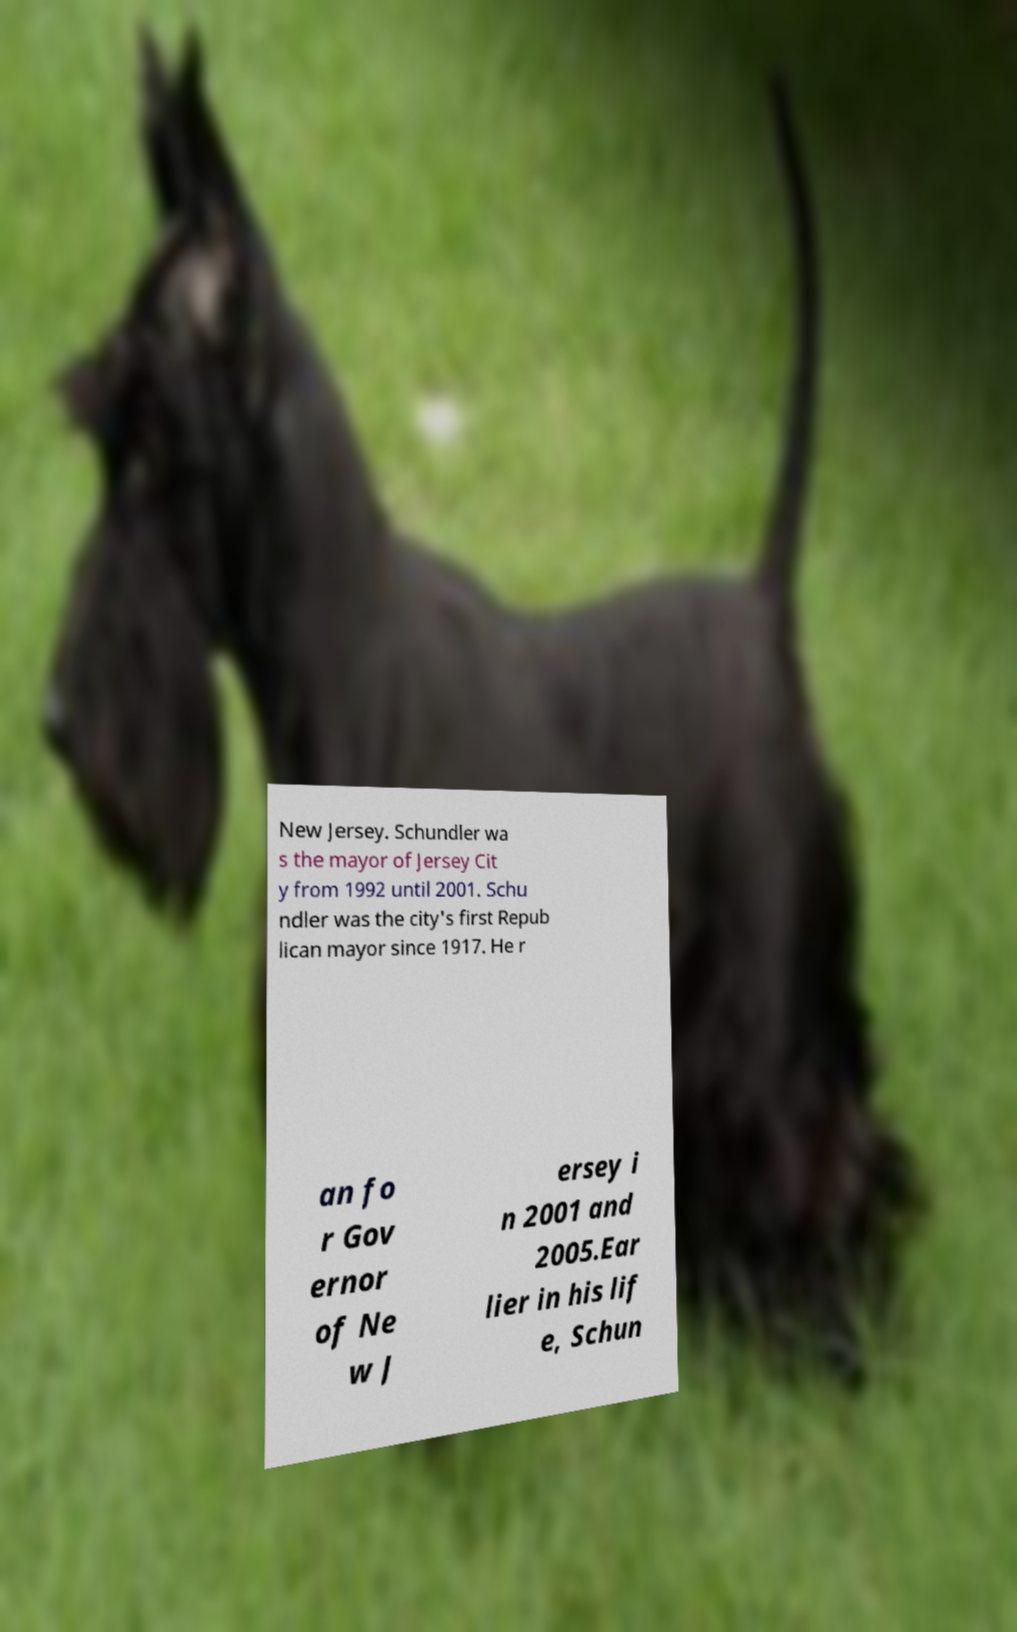Please read and relay the text visible in this image. What does it say? New Jersey. Schundler wa s the mayor of Jersey Cit y from 1992 until 2001. Schu ndler was the city's first Repub lican mayor since 1917. He r an fo r Gov ernor of Ne w J ersey i n 2001 and 2005.Ear lier in his lif e, Schun 